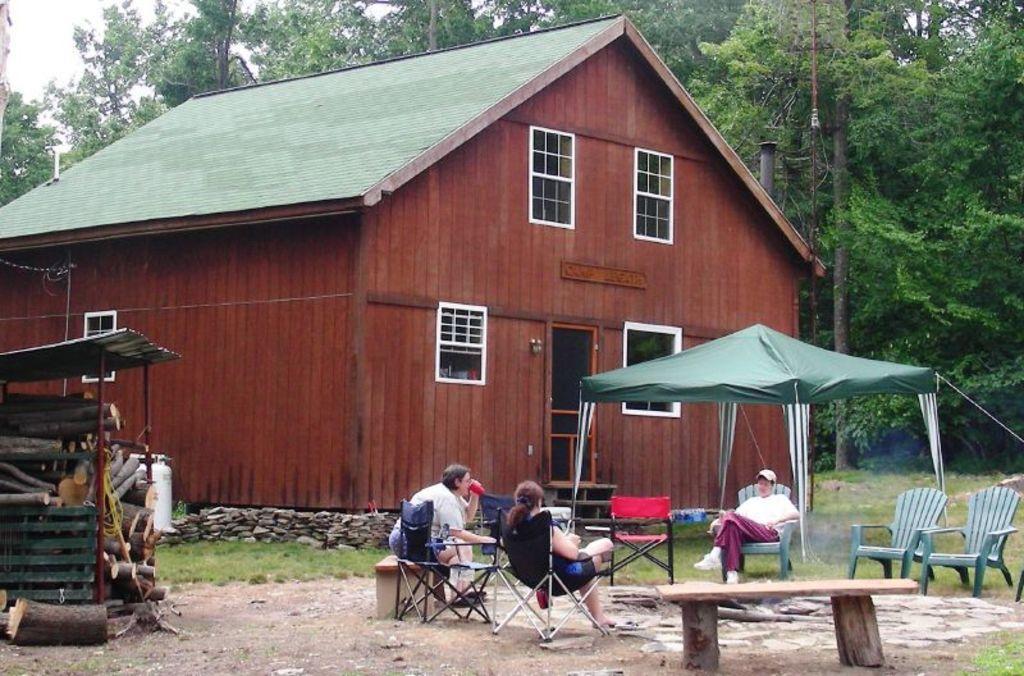How would you summarize this image in a sentence or two? In this image I see 3 persons who are sitting and there are lot of chairs and 2 benches. I can also see there are log of wood over here and In the background I see the house and the trees. 